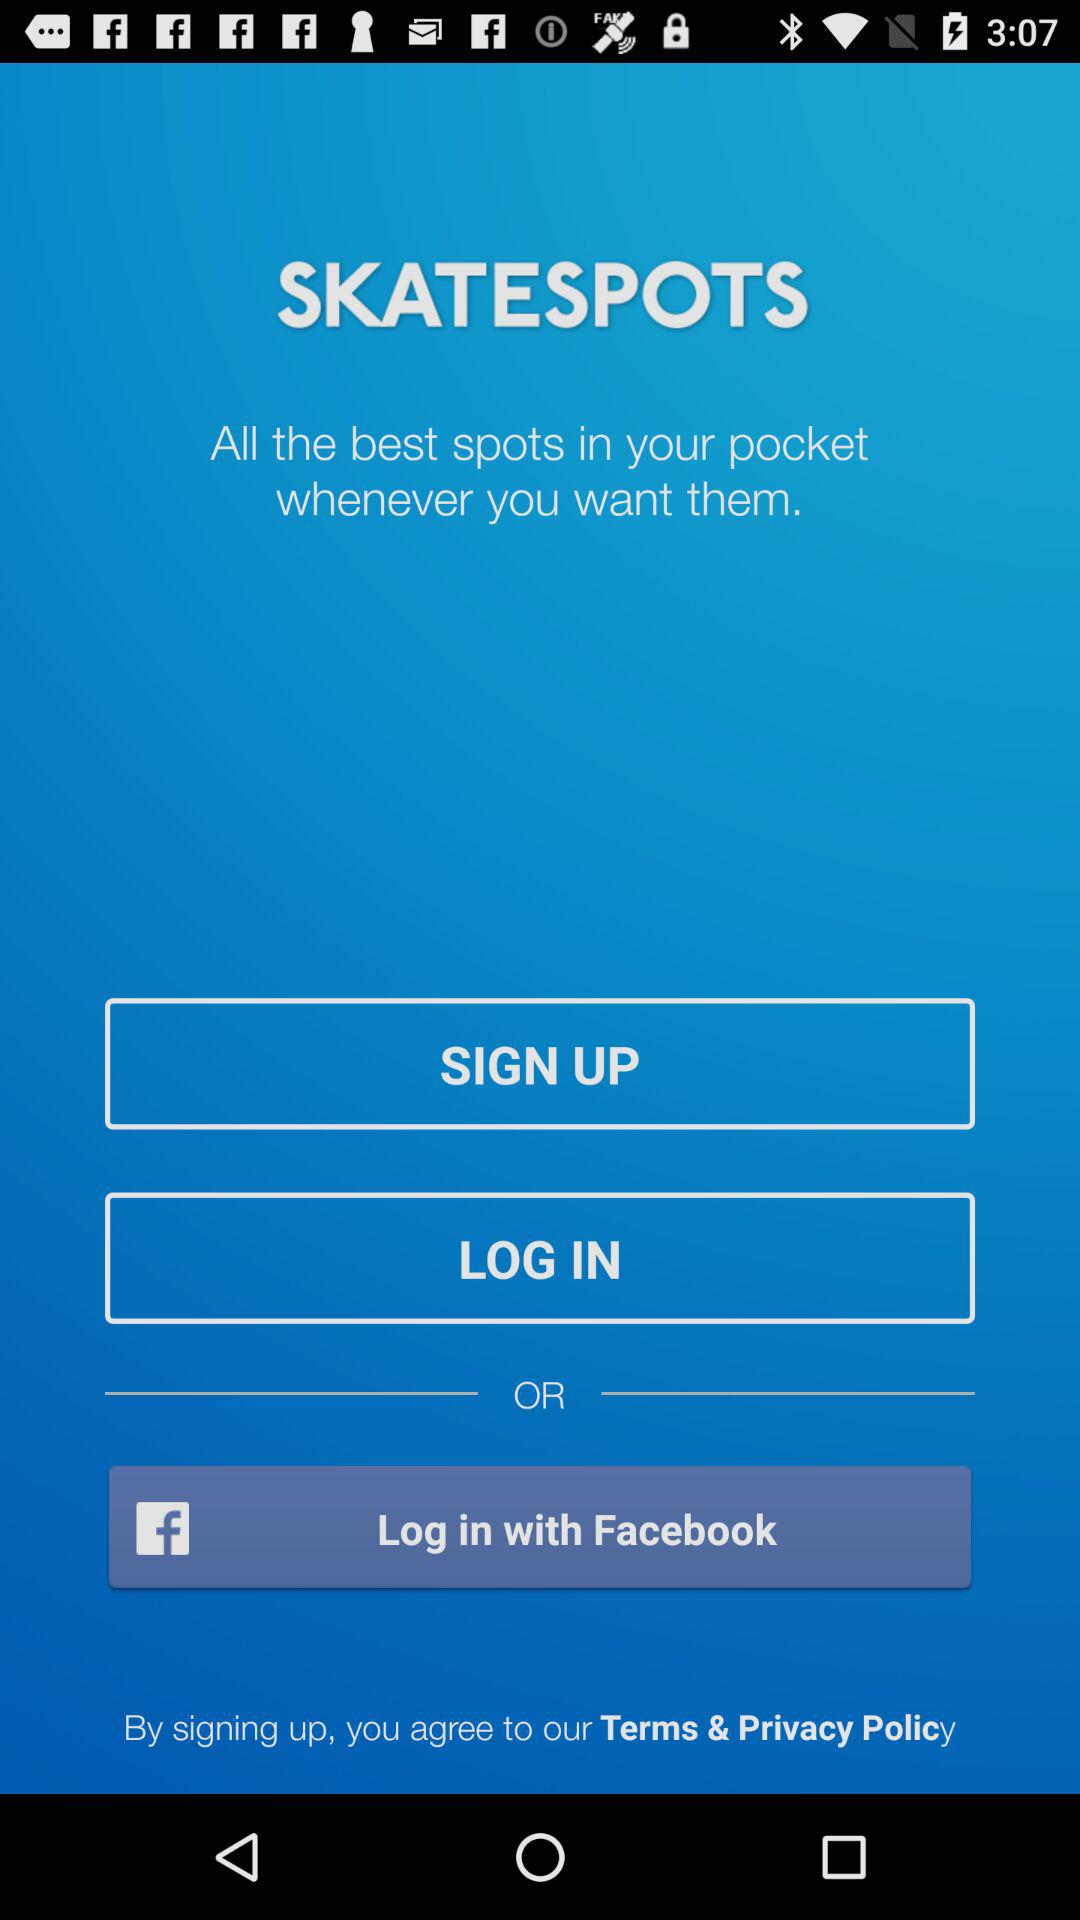What are the different options through which we can log in? You can log in through "Facebook". 